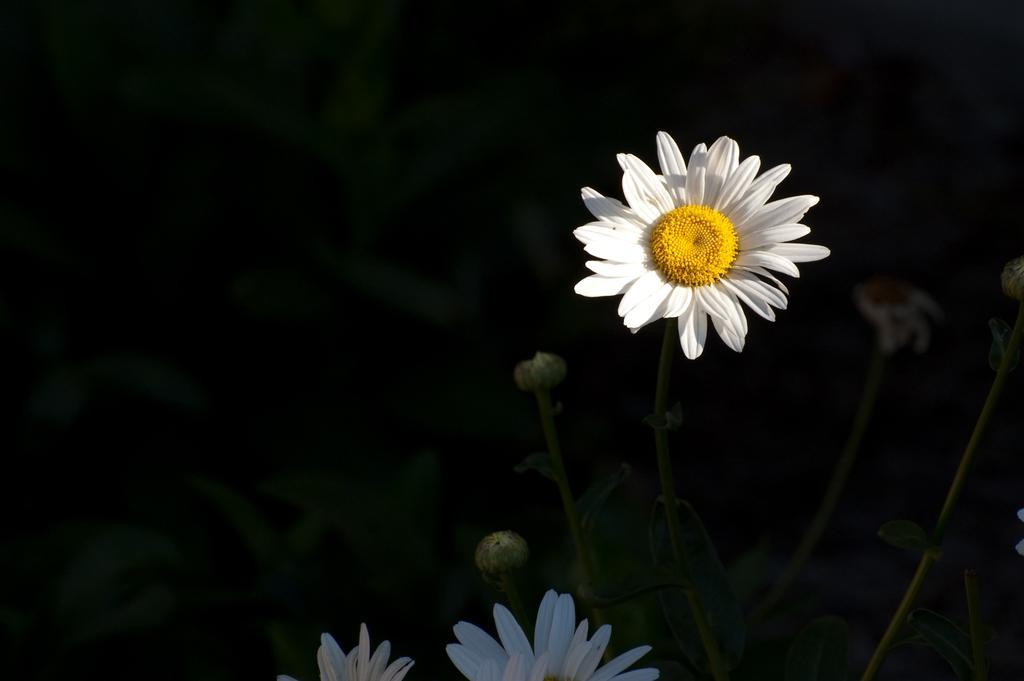Describe this image in one or two sentences. On the right of this picture we can see the flowers and the buds. In the background we can see the leaves and the background of the image is dark. 